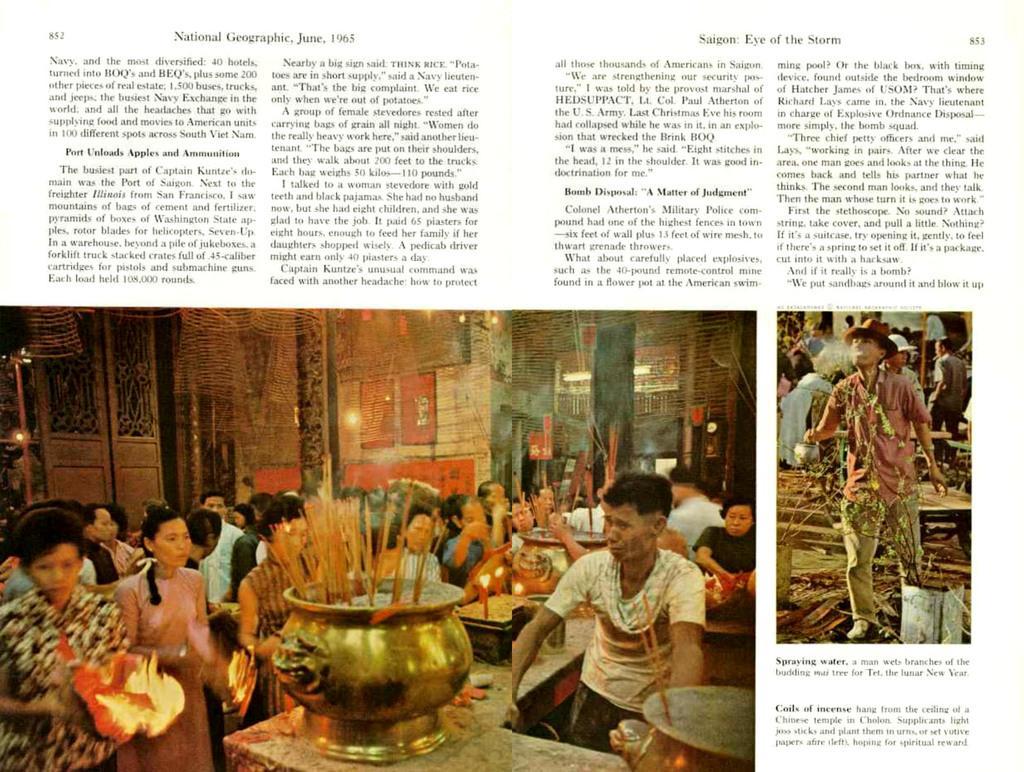Can you describe this image briefly? In this image I can see few pictures of people. On the bottom side of this image I can see few candles and few golden colour things. On the top of this image and on the bottom right side I can see something is written. 